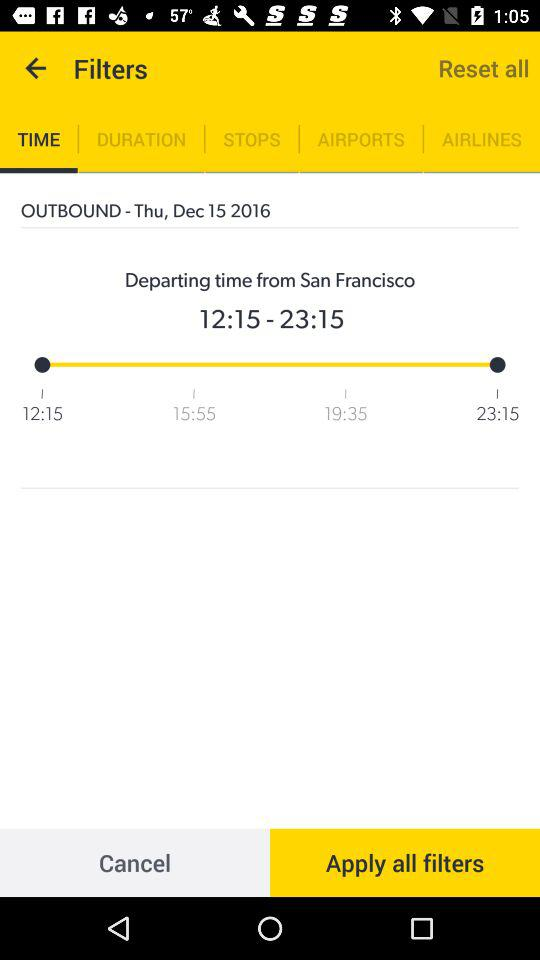What is the date of the outbound? The date is Thursday, December 15, 2016. 